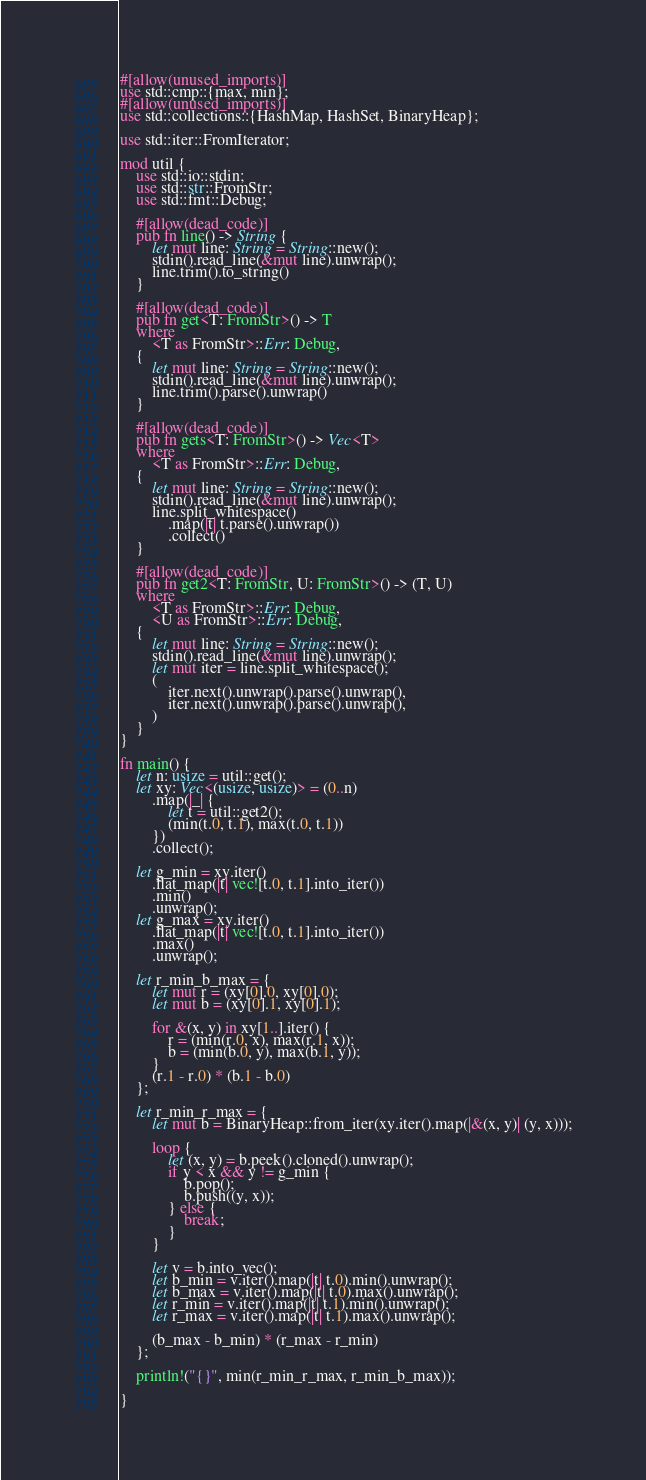<code> <loc_0><loc_0><loc_500><loc_500><_Rust_>#[allow(unused_imports)]
use std::cmp::{max, min};
#[allow(unused_imports)]
use std::collections::{HashMap, HashSet, BinaryHeap};

use std::iter::FromIterator;

mod util {
    use std::io::stdin;
    use std::str::FromStr;
    use std::fmt::Debug;

    #[allow(dead_code)]
    pub fn line() -> String {
        let mut line: String = String::new();
        stdin().read_line(&mut line).unwrap();
        line.trim().to_string()
    }

    #[allow(dead_code)]
    pub fn get<T: FromStr>() -> T
    where
        <T as FromStr>::Err: Debug,
    {
        let mut line: String = String::new();
        stdin().read_line(&mut line).unwrap();
        line.trim().parse().unwrap()
    }

    #[allow(dead_code)]
    pub fn gets<T: FromStr>() -> Vec<T>
    where
        <T as FromStr>::Err: Debug,
    {
        let mut line: String = String::new();
        stdin().read_line(&mut line).unwrap();
        line.split_whitespace()
            .map(|t| t.parse().unwrap())
            .collect()
    }

    #[allow(dead_code)]
    pub fn get2<T: FromStr, U: FromStr>() -> (T, U)
    where
        <T as FromStr>::Err: Debug,
        <U as FromStr>::Err: Debug,
    {
        let mut line: String = String::new();
        stdin().read_line(&mut line).unwrap();
        let mut iter = line.split_whitespace();
        (
            iter.next().unwrap().parse().unwrap(),
            iter.next().unwrap().parse().unwrap(),
        )
    }
}

fn main() {
    let n: usize = util::get();
    let xy: Vec<(usize, usize)> = (0..n)
        .map(|_| {
            let t = util::get2();
            (min(t.0, t.1), max(t.0, t.1))
        })
        .collect();

    let g_min = xy.iter()
        .flat_map(|t| vec![t.0, t.1].into_iter())
        .min()
        .unwrap();
    let g_max = xy.iter()
        .flat_map(|t| vec![t.0, t.1].into_iter())
        .max()
        .unwrap();

    let r_min_b_max = {
        let mut r = (xy[0].0, xy[0].0);
        let mut b = (xy[0].1, xy[0].1);

        for &(x, y) in xy[1..].iter() {
            r = (min(r.0, x), max(r.1, x));
            b = (min(b.0, y), max(b.1, y));
        }
        (r.1 - r.0) * (b.1 - b.0)
    };

    let r_min_r_max = {
        let mut b = BinaryHeap::from_iter(xy.iter().map(|&(x, y)| (y, x)));

        loop {
            let (x, y) = b.peek().cloned().unwrap();
            if y < x && y != g_min {
                b.pop();
                b.push((y, x));
            } else {
                break;
            }
        }

        let v = b.into_vec();
        let b_min = v.iter().map(|t| t.0).min().unwrap();
        let b_max = v.iter().map(|t| t.0).max().unwrap();
        let r_min = v.iter().map(|t| t.1).min().unwrap();
        let r_max = v.iter().map(|t| t.1).max().unwrap();

        (b_max - b_min) * (r_max - r_min)
    };

    println!("{}", min(r_min_r_max, r_min_b_max));

}
</code> 